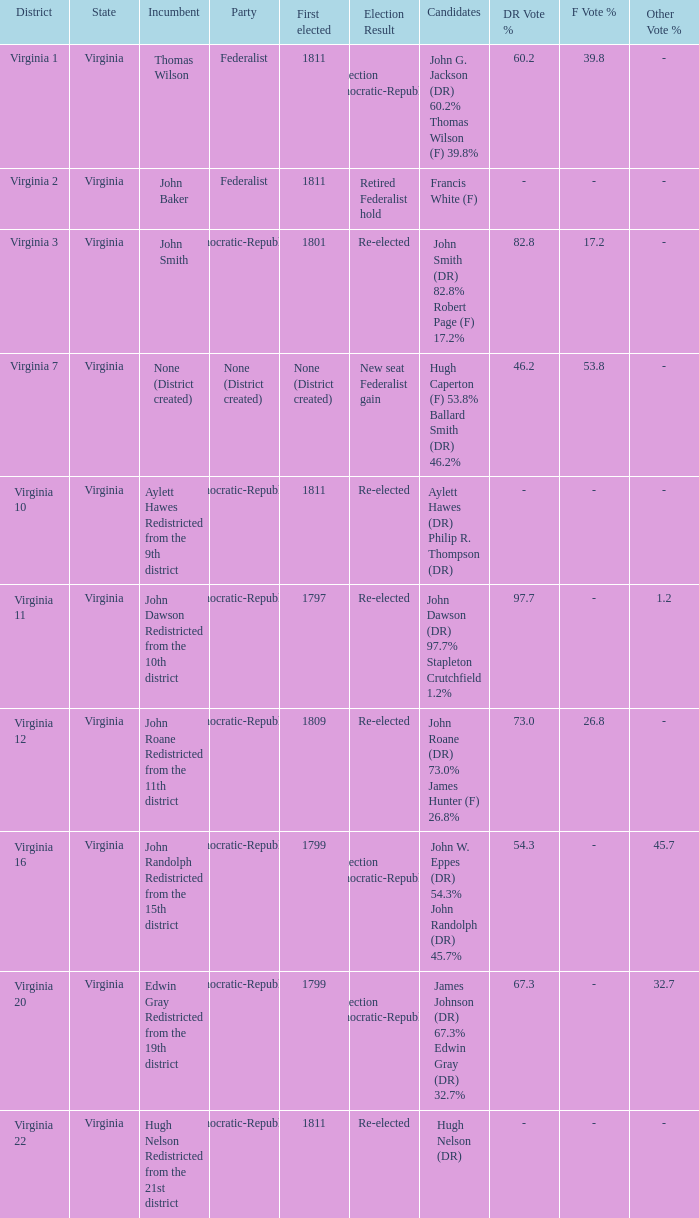Name the party for  john randolph redistricted from the 15th district Democratic-Republican. 